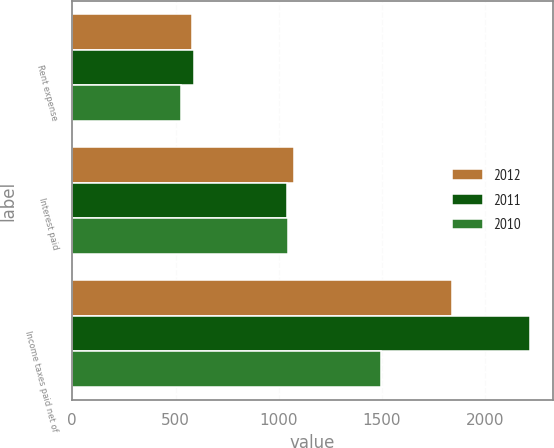<chart> <loc_0><loc_0><loc_500><loc_500><stacked_bar_chart><ecel><fcel>Rent expense<fcel>Interest paid<fcel>Income taxes paid net of<nl><fcel>2012<fcel>581<fcel>1074<fcel>1840<nl><fcel>2011<fcel>589<fcel>1039<fcel>2218<nl><fcel>2010<fcel>526<fcel>1043<fcel>1495<nl></chart> 